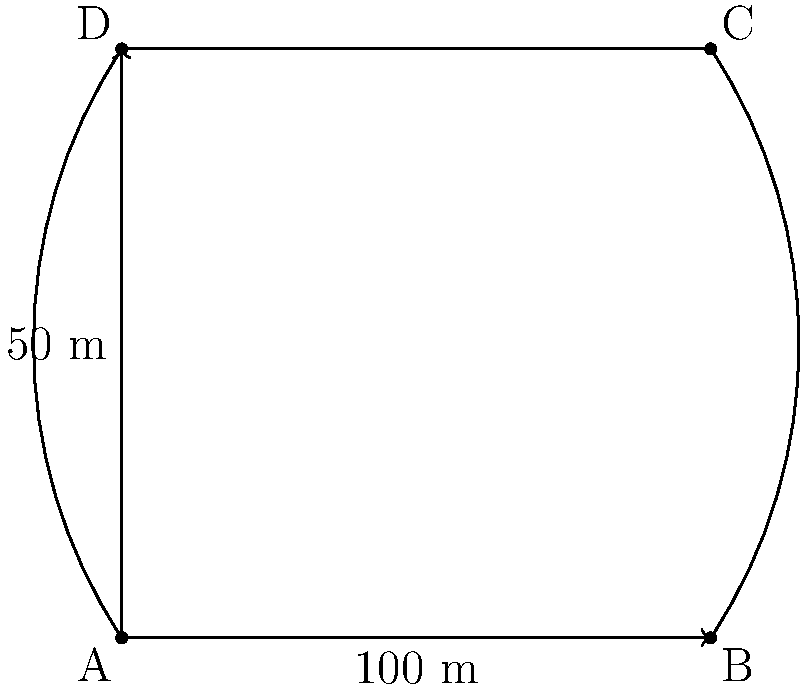Your mom, the nutritionist, wants to calculate your daily calorie burn during track practice. To do this accurately, she needs to know the area of your school's running track. The track has two straight sides of 100 meters each and two curved semicircular ends. If the width of the track is 50 meters, what is the total area of the running track in square meters? Let's break this down step-by-step:

1) The track consists of two parts: a rectangle in the middle and two semicircles at the ends.

2) For the rectangle:
   - Length = 100 m
   - Width = 50 m
   - Area of rectangle = $100 \times 50 = 5000$ sq m

3) For the semicircles:
   - Diameter of each semicircle = width of the track = 50 m
   - Radius of each semicircle = 25 m
   - Area of a full circle = $\pi r^2 = \pi \times 25^2 = 625\pi$ sq m
   - Area of one semicircle = $\frac{1}{2} \times 625\pi = 312.5\pi$ sq m
   - Area of two semicircles = $2 \times 312.5\pi = 625\pi$ sq m

4) Total area:
   - Total area = Area of rectangle + Area of two semicircles
   - Total area = $5000 + 625\pi$ sq m

5) Calculate the final value:
   - $5000 + 625\pi \approx 6963.49$ sq m

Therefore, the total area of the running track is approximately 6963.49 square meters.
Answer: $5000 + 625\pi$ sq m (≈ 6963.49 sq m) 